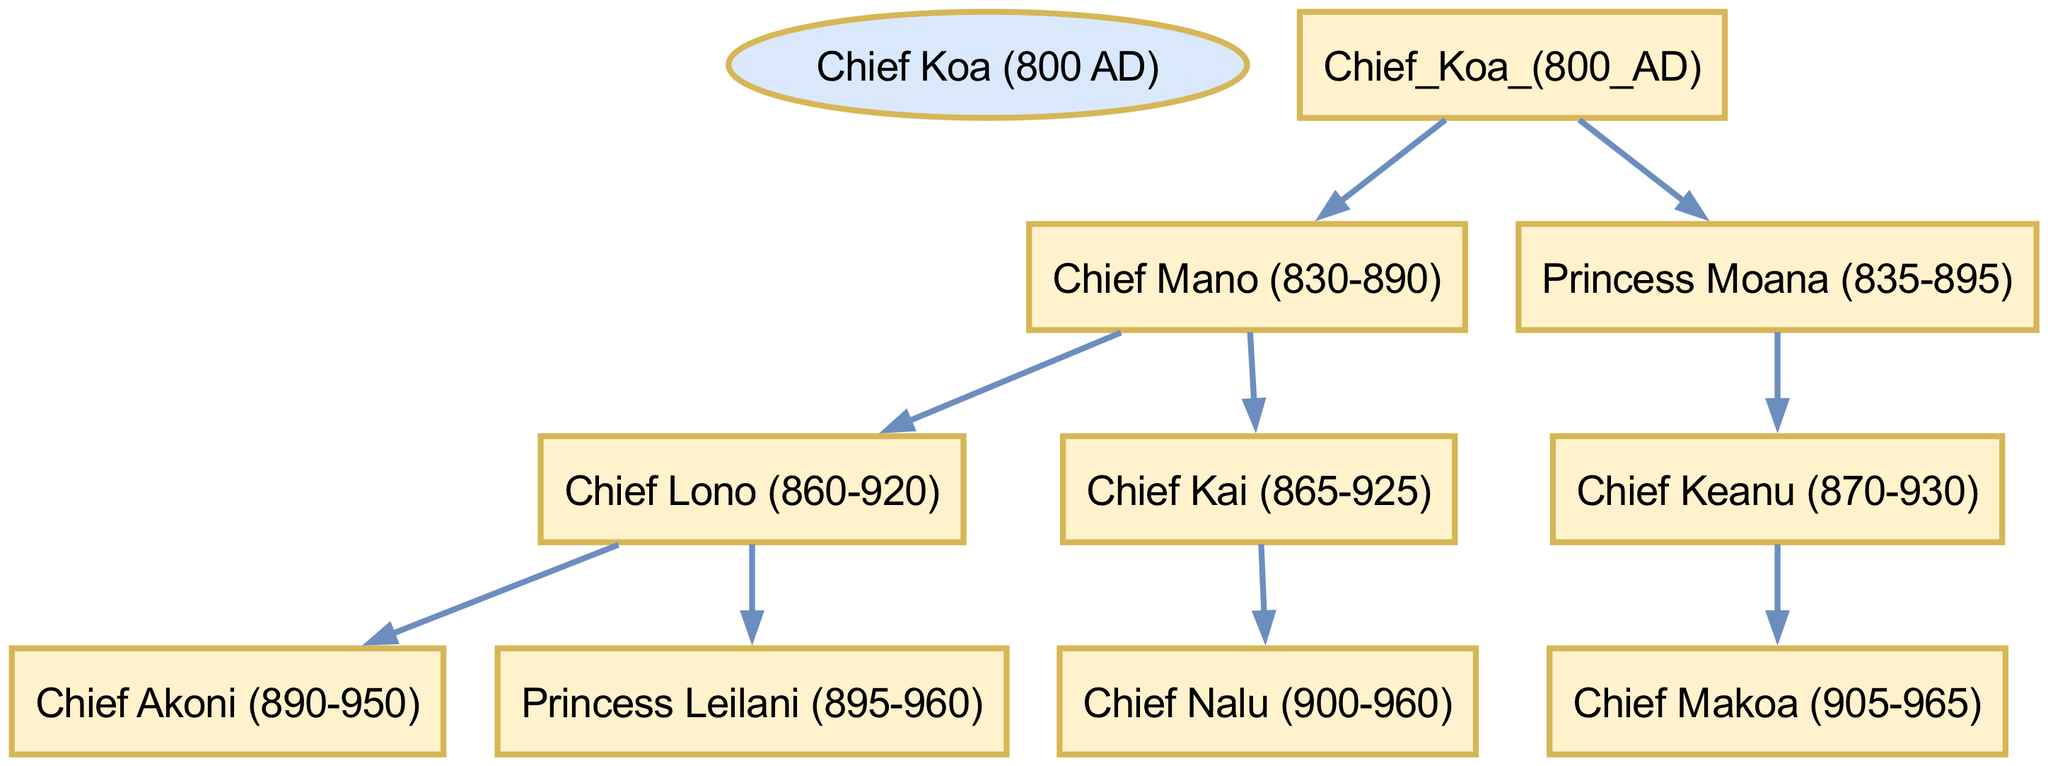What is the name of the root chief? The diagram states the root chief's name at the top of the family tree. It is "Chief Koa."
Answer: Chief Koa How many children does Chief Mano have? Chief Mano is directly connected to two children in the diagram, which are Chief Lono and Chief Kai. Thus, counting these gives the answer.
Answer: 2 Which chief has a daughter named Princess Leilani? Looking at the diagram, it can be seen that Chief Lono is immediately connected to Princess Leilani as one of his children.
Answer: Chief Lono Who is the parent of Chief Makoa? The diagram indicates that Chief Makoa is a child of Chief Keanu, who is depicted under Princess Moana. Thus, tracing the connections leads to Chief Keanu.
Answer: Chief Keanu How many chiefs are there in total? By counting all nodes that have 'Chief' in their names throughout the diagram, we find there are five chiefs: Chief Koa, Chief Mano, Chief Lono, Chief Kai, and Chief Keanu.
Answer: 5 Which princess is related to Chief Nalu? The diagram shows that Chief Nalu is the child of Chief Kai, making the relationship through the male line. Since no direct princess is shown as his child, we note the closest relative, which is Chief Kai and subsequently the whole family structure leads back to family branches.
Answer: Chief Kai What is the lifespan of Chief Akoni? The diagram lists the years next to Chief Akoni's name as 890-950, denoting the years he lived.
Answer: 890-950 Who is the immediate ancestor of Chief Lono? Identifying the direct lineage of Chief Lono in the diagram points to Chief Mano as his immediate parent.
Answer: Chief Mano 